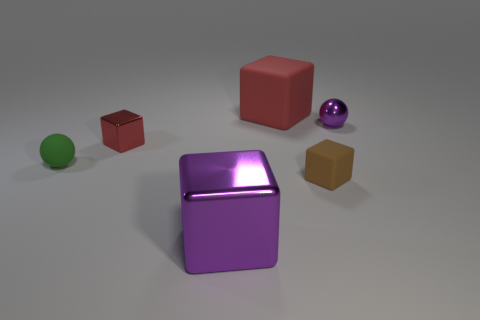Subtract all purple cubes. Subtract all blue cylinders. How many cubes are left? 3 Add 2 big brown cylinders. How many objects exist? 8 Subtract all spheres. How many objects are left? 4 Subtract all small red objects. Subtract all red blocks. How many objects are left? 3 Add 3 big red objects. How many big red objects are left? 4 Add 5 shiny spheres. How many shiny spheres exist? 6 Subtract 0 purple cylinders. How many objects are left? 6 